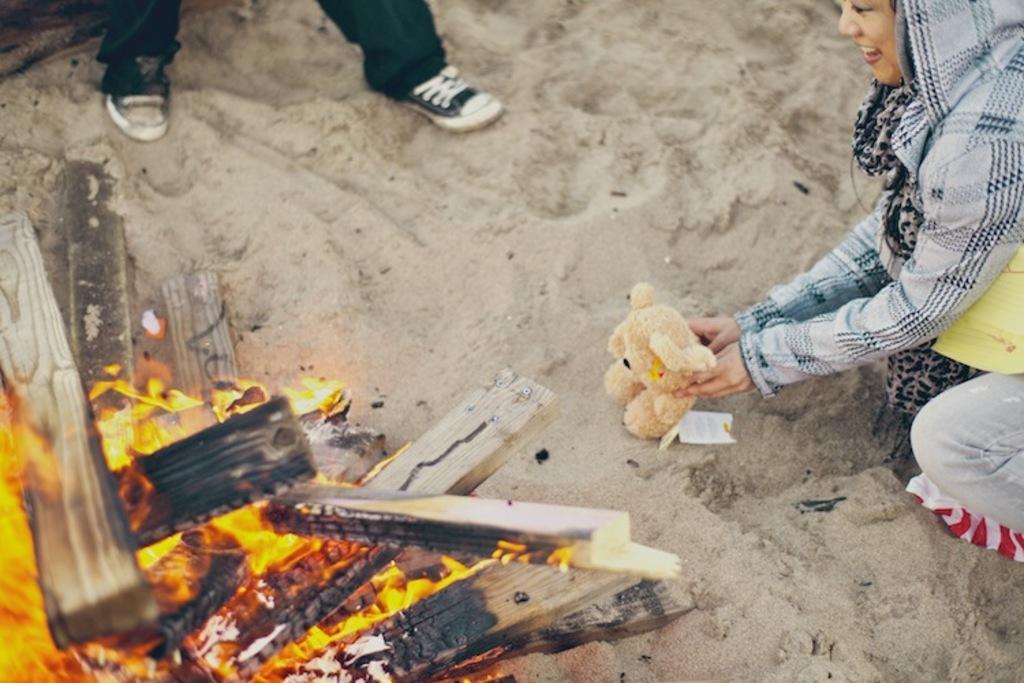Describe this image in one or two sentences. In this picture we can see a bonfire on the sand. Beside there is a girl sitting on the sand and holding the teddy bear in the hand. Behind we can see the person legs. 